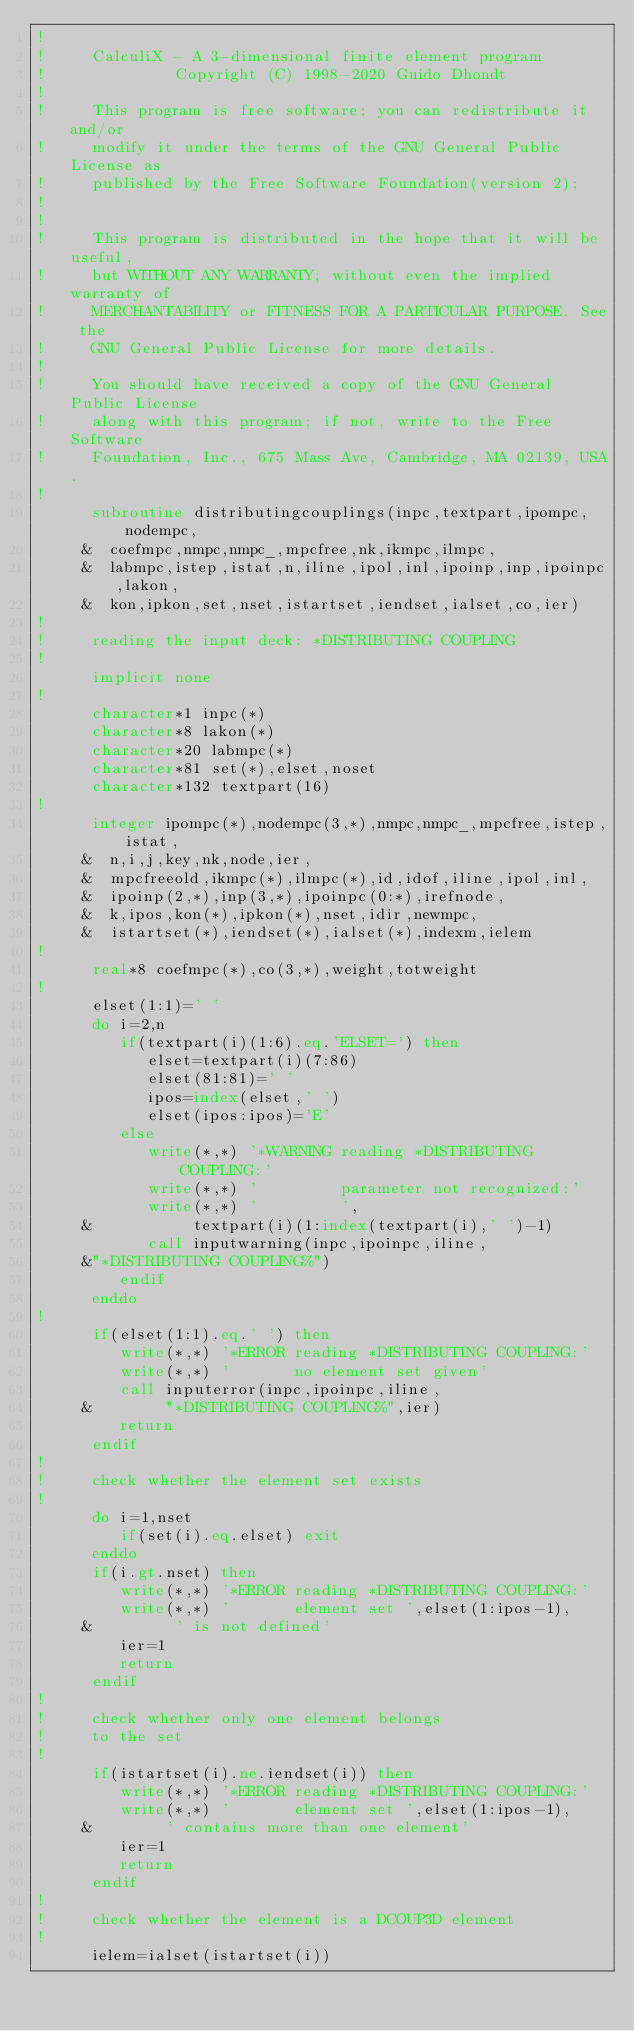<code> <loc_0><loc_0><loc_500><loc_500><_FORTRAN_>!
!     CalculiX - A 3-dimensional finite element program
!              Copyright (C) 1998-2020 Guido Dhondt
!
!     This program is free software; you can redistribute it and/or
!     modify it under the terms of the GNU General Public License as
!     published by the Free Software Foundation(version 2);
!     
!
!     This program is distributed in the hope that it will be useful,
!     but WITHOUT ANY WARRANTY; without even the implied warranty of 
!     MERCHANTABILITY or FITNESS FOR A PARTICULAR PURPOSE. See the 
!     GNU General Public License for more details.
!
!     You should have received a copy of the GNU General Public License
!     along with this program; if not, write to the Free Software
!     Foundation, Inc., 675 Mass Ave, Cambridge, MA 02139, USA.
!
      subroutine distributingcouplings(inpc,textpart,ipompc,nodempc,
     &  coefmpc,nmpc,nmpc_,mpcfree,nk,ikmpc,ilmpc,
     &  labmpc,istep,istat,n,iline,ipol,inl,ipoinp,inp,ipoinpc,lakon,
     &  kon,ipkon,set,nset,istartset,iendset,ialset,co,ier)
!
!     reading the input deck: *DISTRIBUTING COUPLING
!
      implicit none
!
      character*1 inpc(*)
      character*8 lakon(*)
      character*20 labmpc(*)
      character*81 set(*),elset,noset
      character*132 textpart(16)
!
      integer ipompc(*),nodempc(3,*),nmpc,nmpc_,mpcfree,istep,istat,
     &  n,i,j,key,nk,node,ier,
     &  mpcfreeold,ikmpc(*),ilmpc(*),id,idof,iline,ipol,inl,
     &  ipoinp(2,*),inp(3,*),ipoinpc(0:*),irefnode,
     &  k,ipos,kon(*),ipkon(*),nset,idir,newmpc,
     &  istartset(*),iendset(*),ialset(*),indexm,ielem
!
      real*8 coefmpc(*),co(3,*),weight,totweight
!
      elset(1:1)=' '
      do i=2,n
         if(textpart(i)(1:6).eq.'ELSET=') then
            elset=textpart(i)(7:86)
            elset(81:81)=' '
            ipos=index(elset,' ')
            elset(ipos:ipos)='E'
         else
            write(*,*) '*WARNING reading *DISTRIBUTING COUPLING:'
            write(*,*) '         parameter not recognized:'
            write(*,*) '         ',
     &           textpart(i)(1:index(textpart(i),' ')-1)
            call inputwarning(inpc,ipoinpc,iline,
     &"*DISTRIBUTING COUPLING%")
         endif
      enddo
!
      if(elset(1:1).eq.' ') then
         write(*,*) '*ERROR reading *DISTRIBUTING COUPLING:'
         write(*,*) '       no element set given'
         call inputerror(inpc,ipoinpc,iline,
     &        "*DISTRIBUTING COUPLING%",ier)
         return
      endif
!
!     check whether the element set exists
!
      do i=1,nset
         if(set(i).eq.elset) exit
      enddo
      if(i.gt.nset) then
         write(*,*) '*ERROR reading *DISTRIBUTING COUPLING:'
         write(*,*) '       element set ',elset(1:ipos-1),
     &         ' is not defined'
         ier=1
         return
      endif
!
!     check whether only one element belongs
!     to the set
!
      if(istartset(i).ne.iendset(i)) then
         write(*,*) '*ERROR reading *DISTRIBUTING COUPLING:'
         write(*,*) '       element set ',elset(1:ipos-1),
     &        ' contains more than one element'
         ier=1
         return
      endif
!
!     check whether the element is a DCOUP3D element
!
      ielem=ialset(istartset(i))</code> 